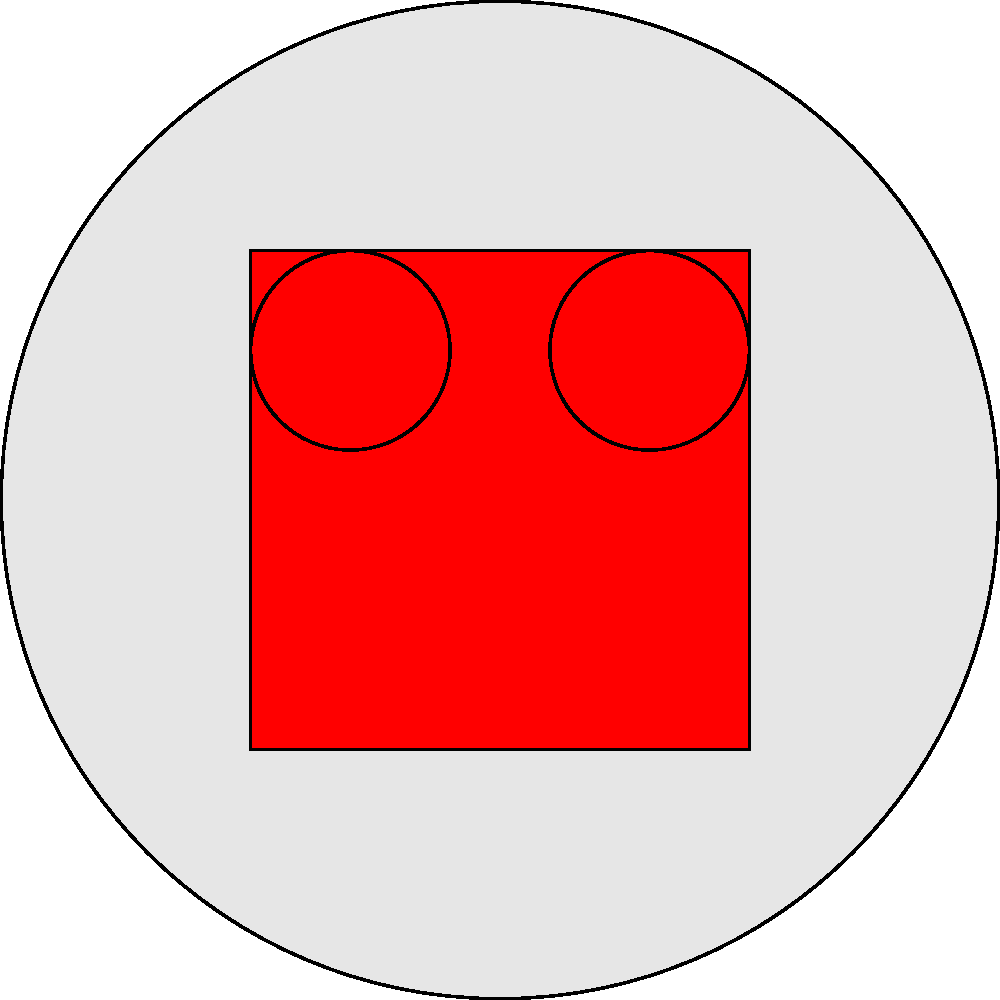Based on the color pattern and markings shown in the image, which Ultra Series character is being represented? To identify the Ultra Series character based on the given color pattern and markings, let's analyze the key features:

1. The overall shape is a circular head, typical of Ultraman characters.
2. There are two large, blue circular eyes positioned symmetrically on the upper part of the face.
3. The most distinctive feature is the color pattern: a red V-shaped marking covering the lower half of the face and extending upwards on both sides.

This color pattern is iconic and immediately recognizable to Ultra Series fans. The red V-shaped marking on a silver body is the signature design of Ultraman, the original and most famous character in the franchise.

Ultraman, who first appeared in the 1966 series, set the standard for many Ultra heroes that followed. His design, with the silver body and red markings, became a template that was often varied but rarely completely abandoned in subsequent series.

The simplicity of the design - just two colors (silver and red) with blue eyes - is also characteristic of the original Ultraman, as later characters often incorporated additional colors or more complex patterns.
Answer: Ultraman 